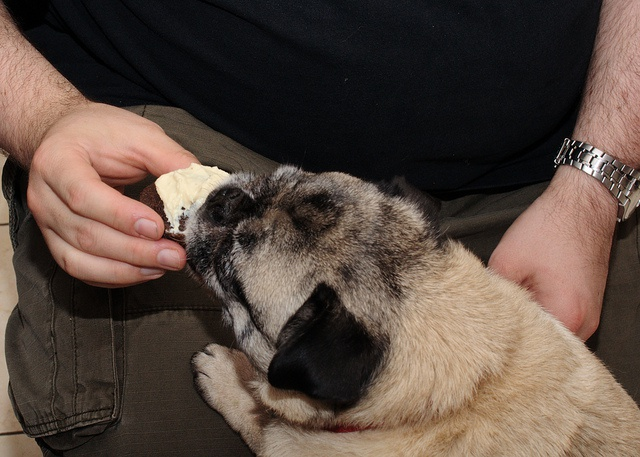Describe the objects in this image and their specific colors. I can see people in black and gray tones, dog in black, tan, and gray tones, people in black, tan, gray, and salmon tones, cake in black, beige, and maroon tones, and donut in black, beige, and maroon tones in this image. 